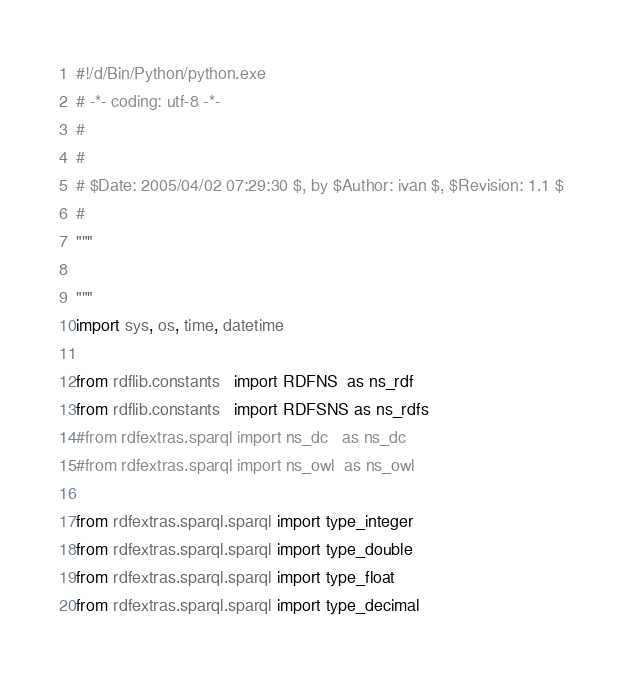<code> <loc_0><loc_0><loc_500><loc_500><_Python_>#!/d/Bin/Python/python.exe
# -*- coding: utf-8 -*-
#
#
# $Date: 2005/04/02 07:29:30 $, by $Author: ivan $, $Revision: 1.1 $
#
"""

"""
import sys, os, time, datetime

from rdflib.constants   import RDFNS  as ns_rdf
from rdflib.constants   import RDFSNS as ns_rdfs
#from rdfextras.sparql import ns_dc   as ns_dc
#from rdfextras.sparql import ns_owl  as ns_owl

from rdfextras.sparql.sparql import type_integer
from rdfextras.sparql.sparql import type_double
from rdfextras.sparql.sparql import type_float
from rdfextras.sparql.sparql import type_decimal</code> 